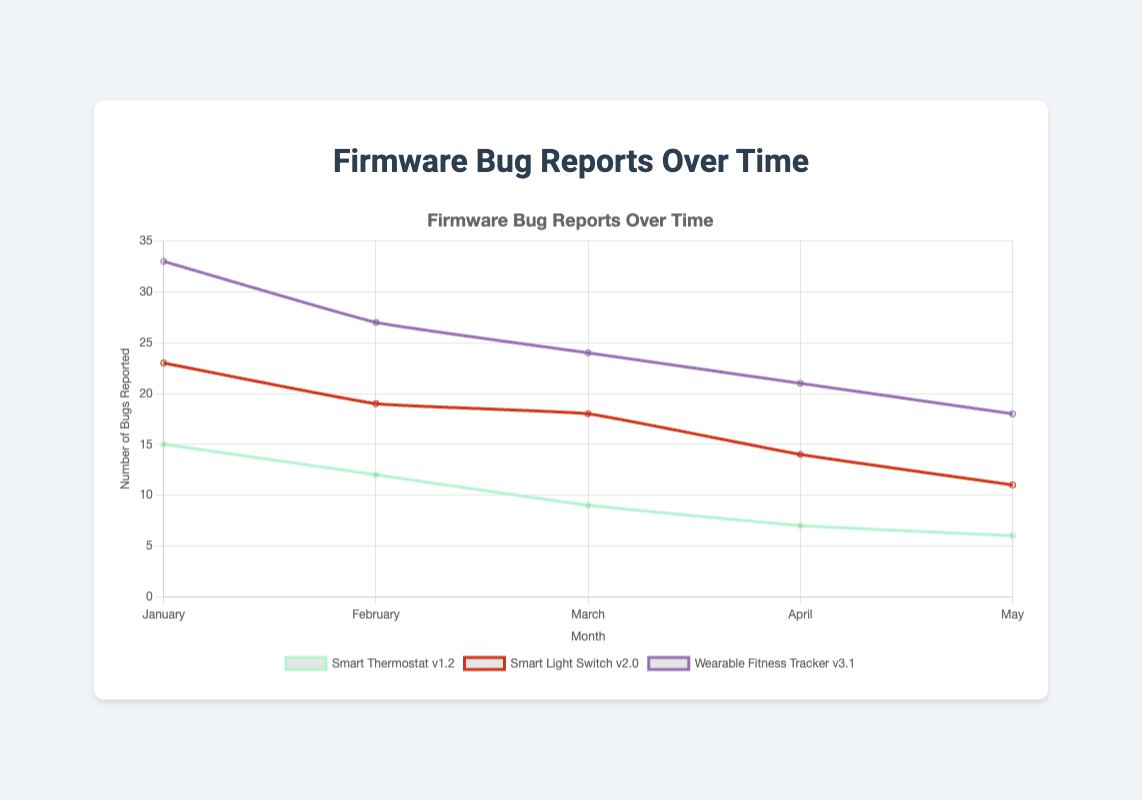What month shows the highest number of bugs reported for Smart Thermostat v1.2? By locating the line specific to "Smart Thermostat v1.2" and following it to the peak value, January 2022 has the highest number of bugs reported at 15.
Answer: January 2022 During which month and year did the Wearable Fitness Tracker v3.1 report the lowest number of bugs? Find the data points for Wearable Fitness Tracker v3.1 and identify the lowest value, which occurs in May 2023 with 18 bugs.
Answer: May 2023 What is the total number of bugs reported for Smart Light Switch v2.0 from January to May 2023? Sum the bugs reported each month: 23 (January) + 19 (February) + 18 (March) + 14 (April) + 11 (May) = 85.
Answer: 85 Which product had the highest number of bugs reported in any single month? By examining the peaks for each product, Wearable Fitness Tracker v3.1 shows the highest number of 33 bugs in January 2023.
Answer: Wearable Fitness Tracker v3.1 Which product shows the most consistent decrease in the number of bugs reported over the observed months? Identify trends by checking the decreasing pattern; Smart Thermostat v1.2 shows consistent decreases in bug reports every month from January to May 2022.
Answer: Smart Thermostat v1.2 Between Smart Light Switch v2.0 and Wearable Fitness Tracker v3.1, which product shows a larger decrease in bugs reported from January to May 2023? Compare the number of bugs reported for each product in January and May: Smart Light Switch v2.0 decreases from 23 to 11 (12 bugs), and Wearable Fitness Tracker v3.1 from 33 to 18 (15 bugs). Therefore, Wearable Fitness Tracker v3.1 shows a larger decrease.
Answer: Wearable Fitness Tracker v3.1 What is the average number of bugs reported for all products in February 2023? Sum the bugs reported for all products in February 2023 and divide by the number of products: (19 + 27) / 2 = 23.
Answer: 23 Are there any months where all products have a decreasing trend in the number of bugs reported compared to the previous month? Check each month's bug reports to see if all products have lower numbers than the previous month; April 2023 and May 2023 both show decreases for Smart Light Switch v2.0 and Wearable Fitness Tracker v3.1 compared to the previous month.
Answer: Yes, April and May 2023 